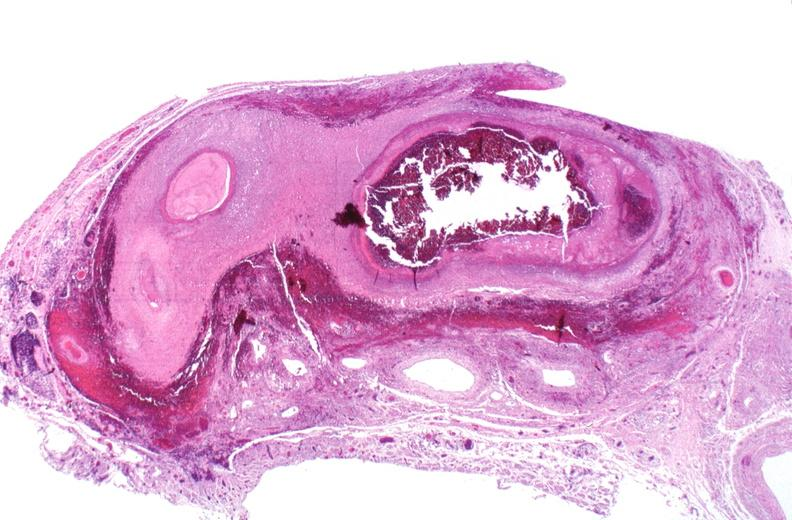what is present?
Answer the question using a single word or phrase. Cardiovascular 